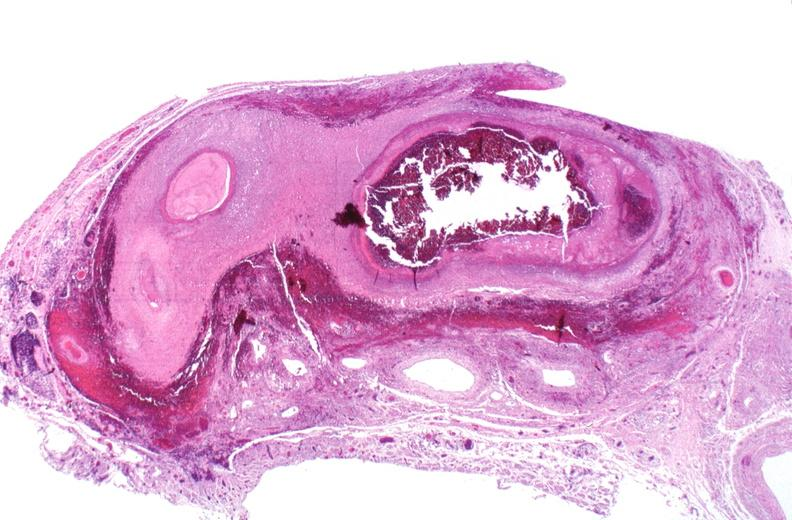what is present?
Answer the question using a single word or phrase. Cardiovascular 